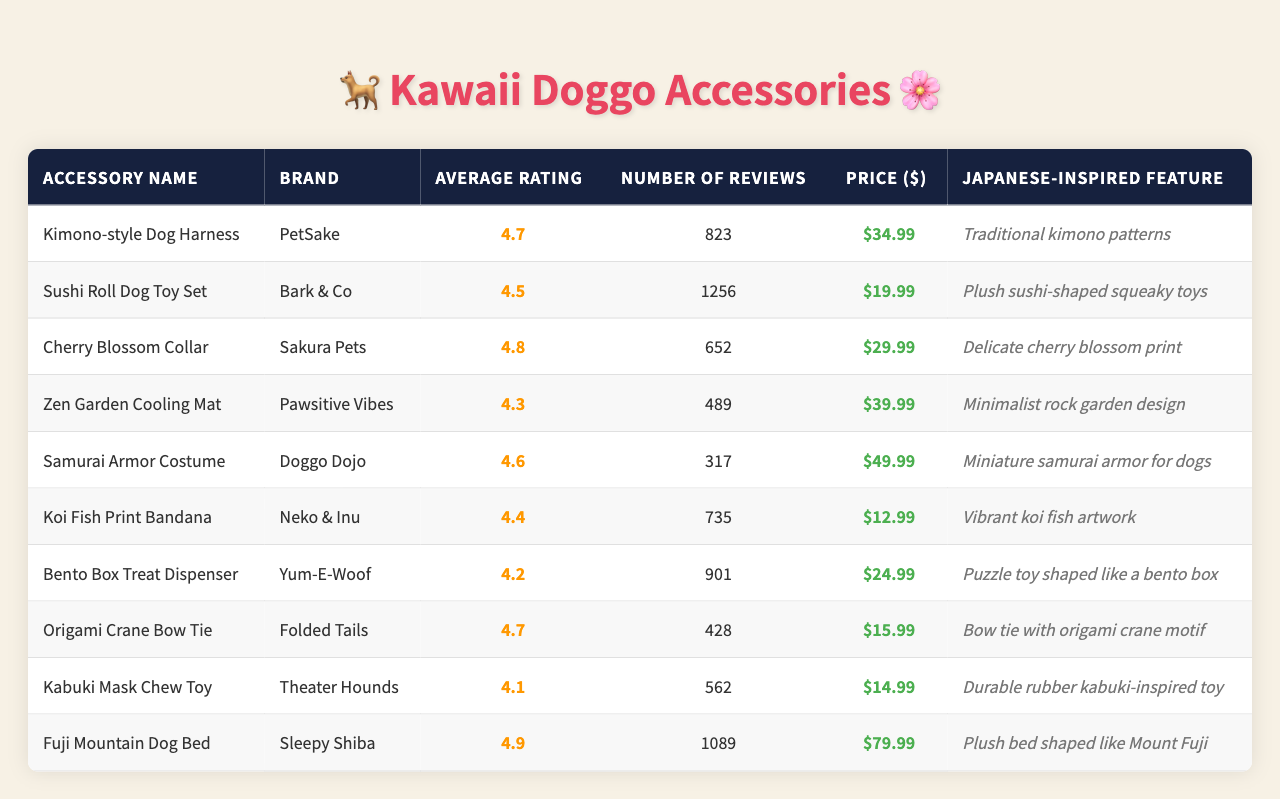What is the average rating of the "Sushi Roll Dog Toy Set"? The average rating is listed directly next to the "Sushi Roll Dog Toy Set," which shows a score of 4.5.
Answer: 4.5 Which dog accessory has the highest average rating? The highest average rating is found by comparing the ratings listed in the table, with the "Fuji Mountain Dog Bed" having a rating of 4.9.
Answer: Fuji Mountain Dog Bed How many reviews does the "Cherry Blossom Collar" have? The number of reviews for the "Cherry Blossom Collar" is indicated as 652 in the corresponding column.
Answer: 652 What is the price of the "Kabuki Mask Chew Toy"? The price is displayed in the table as $14.99.
Answer: $14.99 Which accessory has the least number of reviews? By scanning the number of reviews for each accessory, the "Samurai Armor Costume" has the least reviews at 317.
Answer: Samurai Armor Costume If I want to buy the top two highest-rated accessories, how much would I spend in total? The top two highest-rated accessories are "Fuji Mountain Dog Bed" ($79.99) and "Cherry Blossom Collar" ($29.99). The total is calculated as $79.99 + $29.99 = $109.98.
Answer: $109.98 Is the "Zen Garden Cooling Mat" priced higher or lower than the average price of all accessories? First, calculate the average price: ($34.99 + $19.99 + $29.99 + $39.99 + $49.99 + $12.99 + $24.99 + $15.99 + $14.99 + $79.99)/10 = $34.49. "Zen Garden Cooling Mat" costs $39.99, which is higher than the average.
Answer: Higher List the accessories with a rating of 4.5 or higher. Check the ratings and list those that meet the criteria: "Kimono-style Dog Harness," "Cherry Blossom Collar," "Fuji Mountain Dog Bed," "Origami Crane Bow Tie," and "Samurai Armor Costume."
Answer: 5 accessories Calculate the difference in average rating between the highest and lowest-rated accessories. The highest rating is 4.9 ("Fuji Mountain Dog Bed") and the lowest is 4.1 ("Kabuki Mask Chew Toy"). The difference is 4.9 - 4.1 = 0.8.
Answer: 0.8 Does the "Bento Box Treat Dispenser" feature any Japanese-inspired design? Yes, it features a puzzle toy shaped like a bento box, which is a classic Japanese food container.
Answer: Yes 